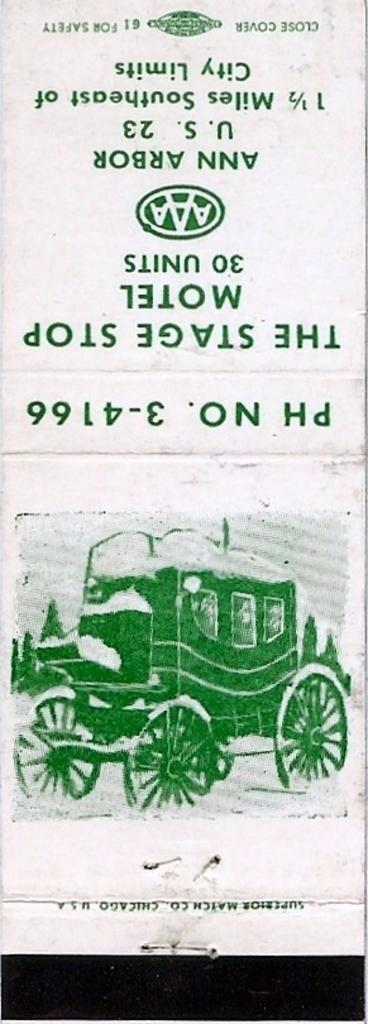What type of visual is the image? The image is a poster. What is depicted on the poster? There is a photo on the poster. What else can be found on the poster besides the photo? There are numbers, words, and symbols on the poster. What type of fear can be seen in the photo on the poster? There is no fear depicted in the photo on the poster, as it is not a subject that can be visually represented in this context. 